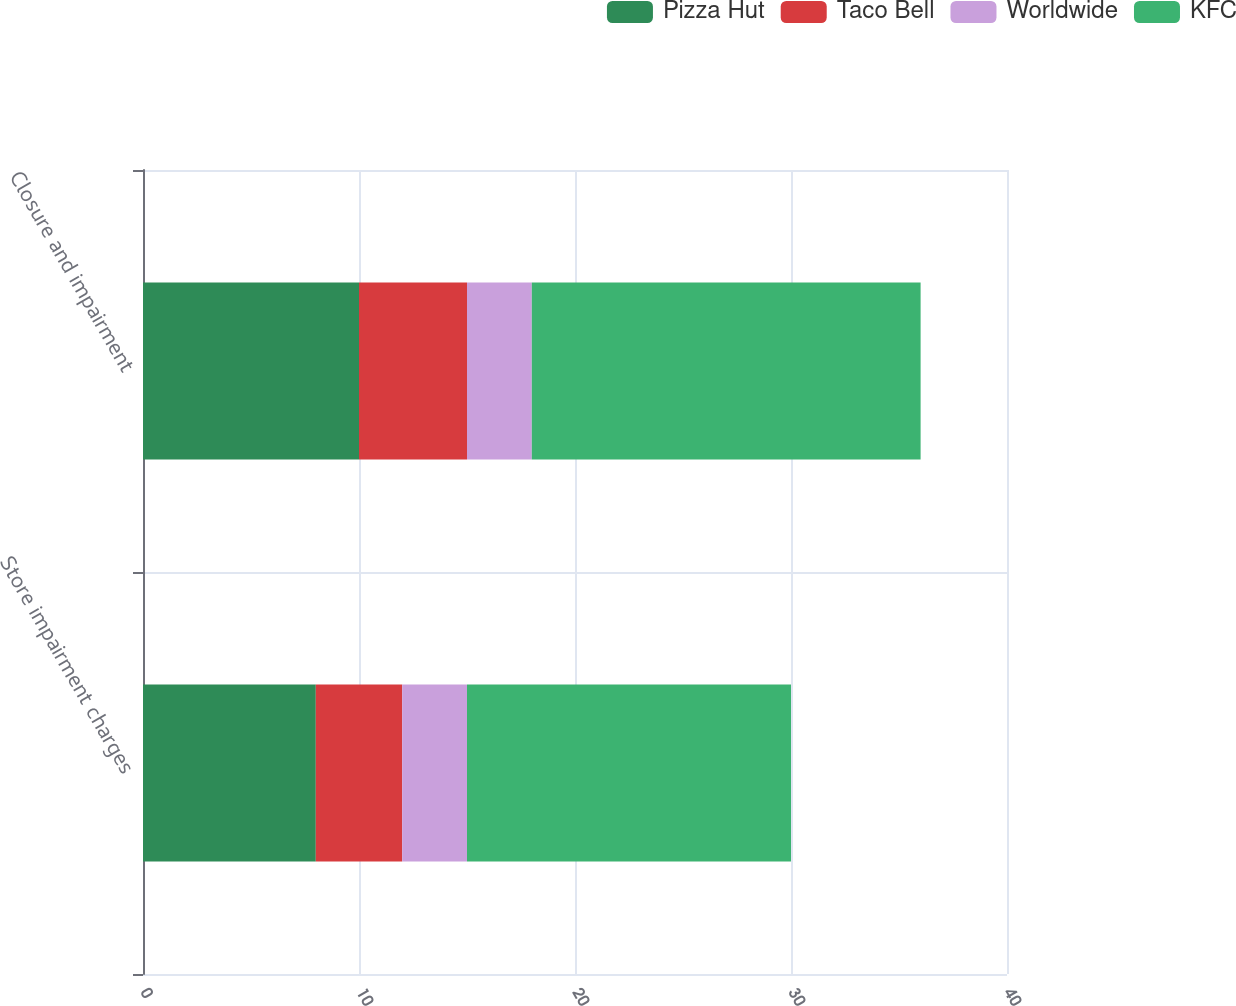Convert chart. <chart><loc_0><loc_0><loc_500><loc_500><stacked_bar_chart><ecel><fcel>Store impairment charges<fcel>Closure and impairment<nl><fcel>Pizza Hut<fcel>8<fcel>10<nl><fcel>Taco Bell<fcel>4<fcel>5<nl><fcel>Worldwide<fcel>3<fcel>3<nl><fcel>KFC<fcel>15<fcel>18<nl></chart> 